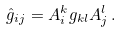Convert formula to latex. <formula><loc_0><loc_0><loc_500><loc_500>\hat { g } _ { i j } = A _ { i } ^ { k } g _ { k l } A _ { j } ^ { l } \, .</formula> 